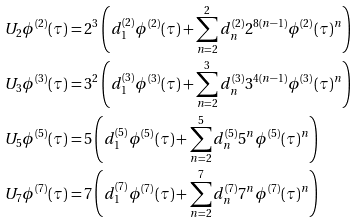Convert formula to latex. <formula><loc_0><loc_0><loc_500><loc_500>U _ { 2 } \phi ^ { ( 2 ) } ( \tau ) & = 2 ^ { 3 } \left ( d _ { 1 } ^ { ( 2 ) } \phi ^ { ( 2 ) } ( \tau ) + \sum _ { n = 2 } ^ { 2 } d _ { n } ^ { ( 2 ) } 2 ^ { 8 ( n - 1 ) } \phi ^ { ( 2 ) } ( \tau ) ^ { n } \right ) \\ U _ { 3 } \phi ^ { ( 3 ) } ( \tau ) & = 3 ^ { 2 } \left ( d _ { 1 } ^ { ( 3 ) } \phi ^ { ( 3 ) } ( \tau ) + \sum _ { n = 2 } ^ { 3 } d _ { n } ^ { ( 3 ) } 3 ^ { 4 ( n - 1 ) } \phi ^ { ( 3 ) } ( \tau ) ^ { n } \right ) \\ U _ { 5 } \phi ^ { ( 5 ) } ( \tau ) & = 5 \left ( d _ { 1 } ^ { ( 5 ) } \phi ^ { ( 5 ) } ( \tau ) + \sum _ { n = 2 } ^ { 5 } d _ { n } ^ { ( 5 ) } 5 ^ { n } \phi ^ { ( 5 ) } ( \tau ) ^ { n } \right ) \\ U _ { 7 } \phi ^ { ( 7 ) } ( \tau ) & = 7 \left ( d _ { 1 } ^ { ( 7 ) } \phi ^ { ( 7 ) } ( \tau ) + \sum _ { n = 2 } ^ { 7 } d _ { n } ^ { ( 7 ) } 7 ^ { n } \phi ^ { ( 7 ) } ( \tau ) ^ { n } \right )</formula> 